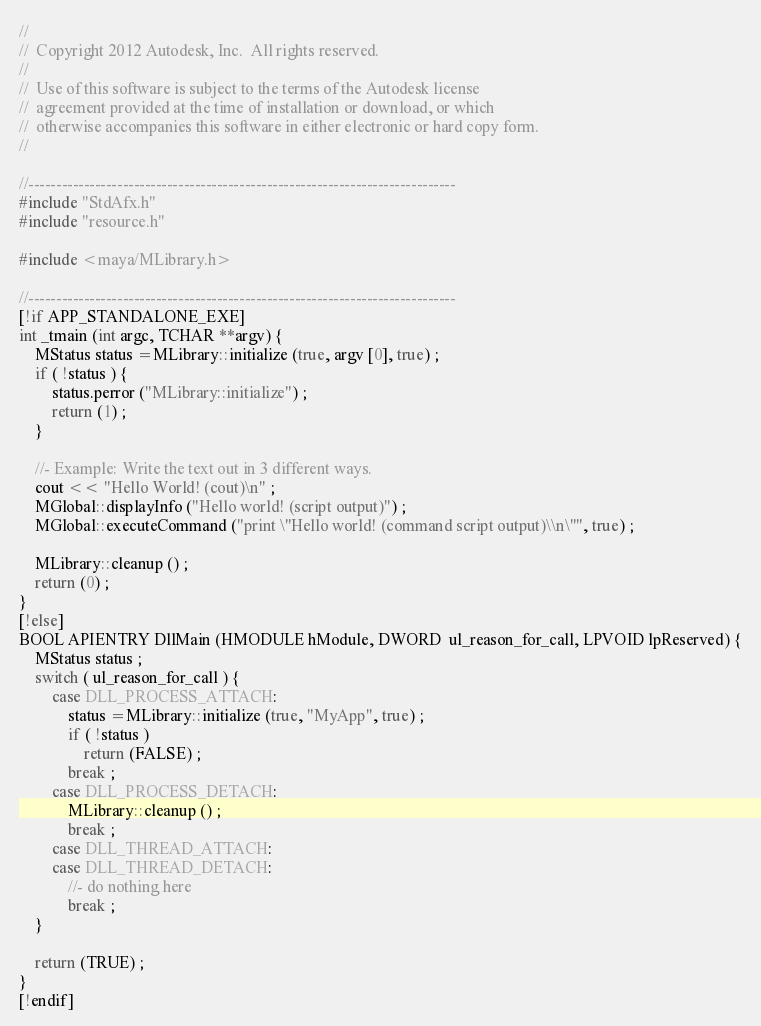Convert code to text. <code><loc_0><loc_0><loc_500><loc_500><_C++_>//
//  Copyright 2012 Autodesk, Inc.  All rights reserved.
//
//  Use of this software is subject to the terms of the Autodesk license 
//  agreement provided at the time of installation or download, or which 
//  otherwise accompanies this software in either electronic or hard copy form.   
//

//-----------------------------------------------------------------------------
#include "StdAfx.h"
#include "resource.h"

#include <maya/MLibrary.h>

//-----------------------------------------------------------------------------
[!if APP_STANDALONE_EXE]
int _tmain (int argc, TCHAR **argv) {
	MStatus status =MLibrary::initialize (true, argv [0], true) ;
	if ( !status ) {
		status.perror ("MLibrary::initialize") ;
		return (1) ;
	}
	
	//- Example: Write the text out in 3 different ways.
	cout << "Hello World! (cout)\n" ;
	MGlobal::displayInfo ("Hello world! (script output)") ;
	MGlobal::executeCommand ("print \"Hello world! (command script output)\\n\"", true) ;

	MLibrary::cleanup () ;
	return (0) ;
}
[!else]
BOOL APIENTRY DllMain (HMODULE hModule, DWORD  ul_reason_for_call, LPVOID lpReserved) {
	MStatus status ;
	switch ( ul_reason_for_call ) {
		case DLL_PROCESS_ATTACH:
			status =MLibrary::initialize (true, "MyApp", true) ;
			if ( !status )
				return (FALSE) ;
			break ;
		case DLL_PROCESS_DETACH:
			MLibrary::cleanup () ;
			break ;
		case DLL_THREAD_ATTACH:
		case DLL_THREAD_DETACH:
			//- do nothing here
			break ;
	}

	return (TRUE) ;
}
[!endif]
</code> 